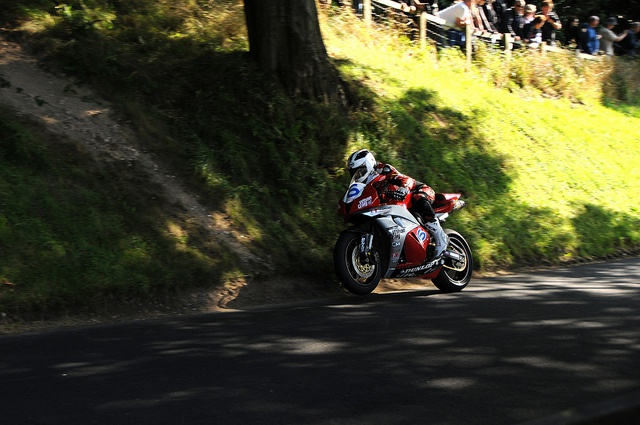Describe the objects in this image and their specific colors. I can see motorcycle in black, gray, maroon, and lightgray tones, people in black, lightgray, gray, and darkgray tones, people in black, white, darkgray, tan, and brown tones, people in black, gray, maroon, and brown tones, and people in black, gray, and darkgray tones in this image. 